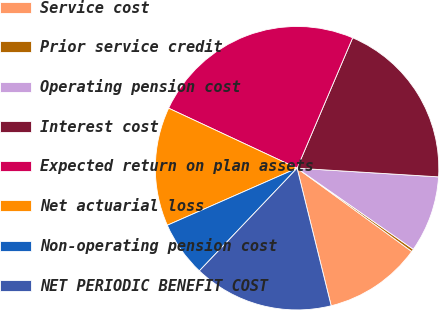Convert chart to OTSL. <chart><loc_0><loc_0><loc_500><loc_500><pie_chart><fcel>Service cost<fcel>Prior service credit<fcel>Operating pension cost<fcel>Interest cost<fcel>Expected return on plan assets<fcel>Net actuarial loss<fcel>Non-operating pension cost<fcel>NET PERIODIC BENEFIT COST<nl><fcel>11.14%<fcel>0.3%<fcel>8.72%<fcel>19.56%<fcel>24.46%<fcel>13.55%<fcel>6.3%<fcel>15.97%<nl></chart> 